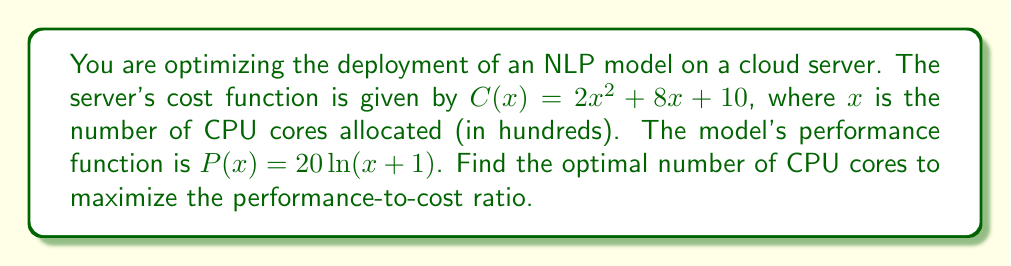Provide a solution to this math problem. To maximize the performance-to-cost ratio, we need to find the maximum of the function $f(x) = \frac{P(x)}{C(x)}$.

1) First, let's write out the function:
   $$f(x) = \frac{P(x)}{C(x)} = \frac{20\ln(x+1)}{2x^2 + 8x + 10}$$

2) To find the maximum, we need to find where the derivative $f'(x) = 0$:
   $$f'(x) = \frac{(20\ln(x+1))'(2x^2 + 8x + 10) - 20\ln(x+1)(2x^2 + 8x + 10)'}{(2x^2 + 8x + 10)^2}$$

3) Simplify:
   $$f'(x) = \frac{20\frac{1}{x+1}(2x^2 + 8x + 10) - 20\ln(x+1)(4x + 8)}{(2x^2 + 8x + 10)^2}$$

4) Set $f'(x) = 0$ and solve:
   $$\frac{20(2x^2 + 8x + 10) - 20(x+1)\ln(x+1)(4x + 8)}{(x+1)(2x^2 + 8x + 10)^2} = 0$$

5) The numerator must equal zero:
   $$2x^2 + 8x + 10 = (x+1)\ln(x+1)(4x + 8)$$

6) This equation can't be solved algebraically. We need to use numerical methods or graphical solutions to find that the solution is approximately $x \approx 0.3947$.

7) Since $x$ represents hundreds of CPU cores, we multiply by 100 to get the actual number of cores.
Answer: 39.47 CPU cores (rounded to 39 or 40 in practice) 